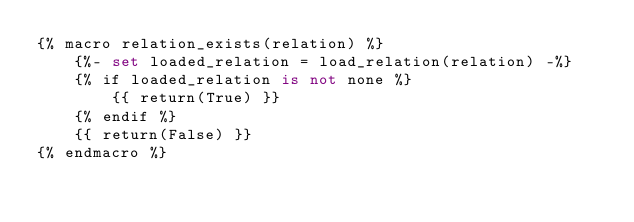<code> <loc_0><loc_0><loc_500><loc_500><_SQL_>{% macro relation_exists(relation) %}
    {%- set loaded_relation = load_relation(relation) -%}
    {% if loaded_relation is not none %}
        {{ return(True) }}
    {% endif %}
    {{ return(False) }}
{% endmacro %}</code> 